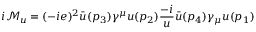<formula> <loc_0><loc_0><loc_500><loc_500>i { \mathcal { M } } _ { u } = ( - i e ) ^ { 2 } { \bar { u } } ( p _ { 3 } ) \gamma ^ { \mu } u ( p _ { 2 } ) { \frac { - i } { u } } { \bar { u } } ( p _ { 4 } ) \gamma _ { \mu } u ( p _ { 1 } )</formula> 